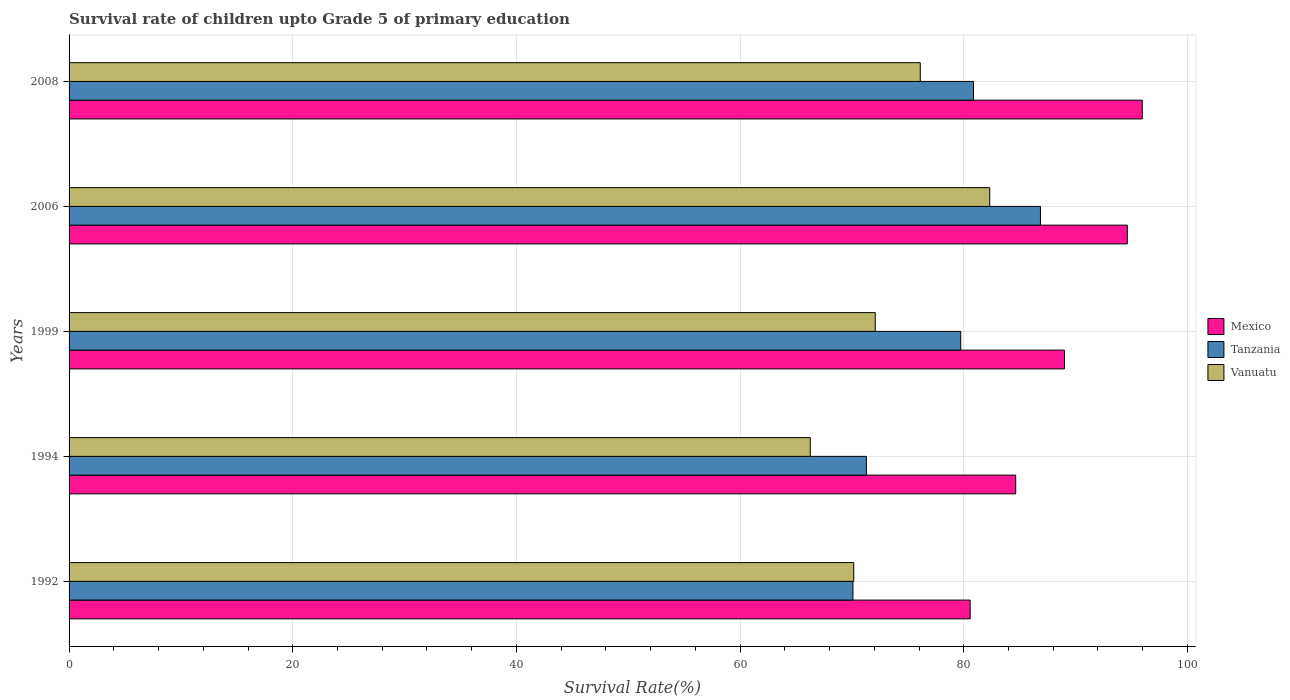Are the number of bars per tick equal to the number of legend labels?
Your response must be concise. Yes. Are the number of bars on each tick of the Y-axis equal?
Ensure brevity in your answer.  Yes. In how many cases, is the number of bars for a given year not equal to the number of legend labels?
Make the answer very short. 0. What is the survival rate of children in Mexico in 2008?
Provide a succinct answer. 95.96. Across all years, what is the maximum survival rate of children in Tanzania?
Provide a short and direct response. 86.86. Across all years, what is the minimum survival rate of children in Vanuatu?
Keep it short and to the point. 66.27. In which year was the survival rate of children in Mexico maximum?
Offer a very short reply. 2008. What is the total survival rate of children in Tanzania in the graph?
Ensure brevity in your answer.  388.84. What is the difference between the survival rate of children in Mexico in 1999 and that in 2008?
Give a very brief answer. -6.95. What is the difference between the survival rate of children in Mexico in 1994 and the survival rate of children in Vanuatu in 1999?
Ensure brevity in your answer.  12.56. What is the average survival rate of children in Mexico per year?
Offer a very short reply. 88.96. In the year 2008, what is the difference between the survival rate of children in Tanzania and survival rate of children in Vanuatu?
Your answer should be very brief. 4.76. In how many years, is the survival rate of children in Tanzania greater than 4 %?
Provide a succinct answer. 5. What is the ratio of the survival rate of children in Mexico in 1999 to that in 2008?
Offer a very short reply. 0.93. Is the survival rate of children in Vanuatu in 1999 less than that in 2006?
Offer a terse response. Yes. Is the difference between the survival rate of children in Tanzania in 1992 and 1994 greater than the difference between the survival rate of children in Vanuatu in 1992 and 1994?
Ensure brevity in your answer.  No. What is the difference between the highest and the second highest survival rate of children in Vanuatu?
Offer a very short reply. 6.21. What is the difference between the highest and the lowest survival rate of children in Mexico?
Make the answer very short. 15.39. In how many years, is the survival rate of children in Vanuatu greater than the average survival rate of children in Vanuatu taken over all years?
Offer a terse response. 2. What does the 2nd bar from the top in 2008 represents?
Your response must be concise. Tanzania. What does the 2nd bar from the bottom in 2006 represents?
Your response must be concise. Tanzania. How many bars are there?
Provide a succinct answer. 15. How many years are there in the graph?
Give a very brief answer. 5. What is the difference between two consecutive major ticks on the X-axis?
Keep it short and to the point. 20. How are the legend labels stacked?
Keep it short and to the point. Vertical. What is the title of the graph?
Provide a succinct answer. Survival rate of children upto Grade 5 of primary education. What is the label or title of the X-axis?
Offer a very short reply. Survival Rate(%). What is the Survival Rate(%) of Mexico in 1992?
Your response must be concise. 80.57. What is the Survival Rate(%) in Tanzania in 1992?
Provide a short and direct response. 70.09. What is the Survival Rate(%) of Vanuatu in 1992?
Keep it short and to the point. 70.16. What is the Survival Rate(%) of Mexico in 1994?
Offer a terse response. 84.64. What is the Survival Rate(%) of Tanzania in 1994?
Keep it short and to the point. 71.29. What is the Survival Rate(%) of Vanuatu in 1994?
Provide a short and direct response. 66.27. What is the Survival Rate(%) of Mexico in 1999?
Provide a short and direct response. 89. What is the Survival Rate(%) in Tanzania in 1999?
Make the answer very short. 79.73. What is the Survival Rate(%) in Vanuatu in 1999?
Provide a short and direct response. 72.08. What is the Survival Rate(%) of Mexico in 2006?
Provide a succinct answer. 94.62. What is the Survival Rate(%) of Tanzania in 2006?
Your response must be concise. 86.86. What is the Survival Rate(%) in Vanuatu in 2006?
Ensure brevity in your answer.  82.32. What is the Survival Rate(%) of Mexico in 2008?
Give a very brief answer. 95.96. What is the Survival Rate(%) in Tanzania in 2008?
Make the answer very short. 80.87. What is the Survival Rate(%) in Vanuatu in 2008?
Make the answer very short. 76.11. Across all years, what is the maximum Survival Rate(%) in Mexico?
Offer a terse response. 95.96. Across all years, what is the maximum Survival Rate(%) in Tanzania?
Offer a very short reply. 86.86. Across all years, what is the maximum Survival Rate(%) of Vanuatu?
Offer a terse response. 82.32. Across all years, what is the minimum Survival Rate(%) in Mexico?
Provide a short and direct response. 80.57. Across all years, what is the minimum Survival Rate(%) in Tanzania?
Provide a short and direct response. 70.09. Across all years, what is the minimum Survival Rate(%) in Vanuatu?
Ensure brevity in your answer.  66.27. What is the total Survival Rate(%) in Mexico in the graph?
Keep it short and to the point. 444.8. What is the total Survival Rate(%) in Tanzania in the graph?
Provide a succinct answer. 388.84. What is the total Survival Rate(%) of Vanuatu in the graph?
Give a very brief answer. 366.95. What is the difference between the Survival Rate(%) of Mexico in 1992 and that in 1994?
Offer a terse response. -4.07. What is the difference between the Survival Rate(%) of Tanzania in 1992 and that in 1994?
Your answer should be very brief. -1.2. What is the difference between the Survival Rate(%) of Vanuatu in 1992 and that in 1994?
Offer a terse response. 3.89. What is the difference between the Survival Rate(%) of Mexico in 1992 and that in 1999?
Give a very brief answer. -8.43. What is the difference between the Survival Rate(%) in Tanzania in 1992 and that in 1999?
Your response must be concise. -9.64. What is the difference between the Survival Rate(%) in Vanuatu in 1992 and that in 1999?
Give a very brief answer. -1.92. What is the difference between the Survival Rate(%) in Mexico in 1992 and that in 2006?
Provide a short and direct response. -14.05. What is the difference between the Survival Rate(%) of Tanzania in 1992 and that in 2006?
Offer a terse response. -16.77. What is the difference between the Survival Rate(%) in Vanuatu in 1992 and that in 2006?
Keep it short and to the point. -12.16. What is the difference between the Survival Rate(%) of Mexico in 1992 and that in 2008?
Keep it short and to the point. -15.39. What is the difference between the Survival Rate(%) in Tanzania in 1992 and that in 2008?
Keep it short and to the point. -10.77. What is the difference between the Survival Rate(%) in Vanuatu in 1992 and that in 2008?
Your answer should be very brief. -5.95. What is the difference between the Survival Rate(%) in Mexico in 1994 and that in 1999?
Offer a terse response. -4.36. What is the difference between the Survival Rate(%) of Tanzania in 1994 and that in 1999?
Keep it short and to the point. -8.43. What is the difference between the Survival Rate(%) of Vanuatu in 1994 and that in 1999?
Give a very brief answer. -5.81. What is the difference between the Survival Rate(%) of Mexico in 1994 and that in 2006?
Offer a very short reply. -9.98. What is the difference between the Survival Rate(%) in Tanzania in 1994 and that in 2006?
Provide a succinct answer. -15.56. What is the difference between the Survival Rate(%) in Vanuatu in 1994 and that in 2006?
Keep it short and to the point. -16.05. What is the difference between the Survival Rate(%) in Mexico in 1994 and that in 2008?
Provide a short and direct response. -11.32. What is the difference between the Survival Rate(%) in Tanzania in 1994 and that in 2008?
Your response must be concise. -9.57. What is the difference between the Survival Rate(%) in Vanuatu in 1994 and that in 2008?
Keep it short and to the point. -9.84. What is the difference between the Survival Rate(%) of Mexico in 1999 and that in 2006?
Ensure brevity in your answer.  -5.62. What is the difference between the Survival Rate(%) of Tanzania in 1999 and that in 2006?
Make the answer very short. -7.13. What is the difference between the Survival Rate(%) in Vanuatu in 1999 and that in 2006?
Make the answer very short. -10.24. What is the difference between the Survival Rate(%) in Mexico in 1999 and that in 2008?
Keep it short and to the point. -6.95. What is the difference between the Survival Rate(%) in Tanzania in 1999 and that in 2008?
Give a very brief answer. -1.14. What is the difference between the Survival Rate(%) of Vanuatu in 1999 and that in 2008?
Give a very brief answer. -4.03. What is the difference between the Survival Rate(%) of Mexico in 2006 and that in 2008?
Keep it short and to the point. -1.34. What is the difference between the Survival Rate(%) in Tanzania in 2006 and that in 2008?
Offer a very short reply. 5.99. What is the difference between the Survival Rate(%) of Vanuatu in 2006 and that in 2008?
Your response must be concise. 6.21. What is the difference between the Survival Rate(%) of Mexico in 1992 and the Survival Rate(%) of Tanzania in 1994?
Your answer should be very brief. 9.28. What is the difference between the Survival Rate(%) in Mexico in 1992 and the Survival Rate(%) in Vanuatu in 1994?
Your response must be concise. 14.3. What is the difference between the Survival Rate(%) of Tanzania in 1992 and the Survival Rate(%) of Vanuatu in 1994?
Provide a short and direct response. 3.82. What is the difference between the Survival Rate(%) of Mexico in 1992 and the Survival Rate(%) of Tanzania in 1999?
Give a very brief answer. 0.84. What is the difference between the Survival Rate(%) of Mexico in 1992 and the Survival Rate(%) of Vanuatu in 1999?
Make the answer very short. 8.49. What is the difference between the Survival Rate(%) of Tanzania in 1992 and the Survival Rate(%) of Vanuatu in 1999?
Keep it short and to the point. -1.99. What is the difference between the Survival Rate(%) of Mexico in 1992 and the Survival Rate(%) of Tanzania in 2006?
Make the answer very short. -6.29. What is the difference between the Survival Rate(%) in Mexico in 1992 and the Survival Rate(%) in Vanuatu in 2006?
Offer a very short reply. -1.75. What is the difference between the Survival Rate(%) in Tanzania in 1992 and the Survival Rate(%) in Vanuatu in 2006?
Provide a succinct answer. -12.23. What is the difference between the Survival Rate(%) of Mexico in 1992 and the Survival Rate(%) of Tanzania in 2008?
Provide a short and direct response. -0.29. What is the difference between the Survival Rate(%) of Mexico in 1992 and the Survival Rate(%) of Vanuatu in 2008?
Keep it short and to the point. 4.46. What is the difference between the Survival Rate(%) in Tanzania in 1992 and the Survival Rate(%) in Vanuatu in 2008?
Your response must be concise. -6.02. What is the difference between the Survival Rate(%) in Mexico in 1994 and the Survival Rate(%) in Tanzania in 1999?
Your answer should be compact. 4.91. What is the difference between the Survival Rate(%) in Mexico in 1994 and the Survival Rate(%) in Vanuatu in 1999?
Offer a very short reply. 12.56. What is the difference between the Survival Rate(%) in Tanzania in 1994 and the Survival Rate(%) in Vanuatu in 1999?
Keep it short and to the point. -0.79. What is the difference between the Survival Rate(%) in Mexico in 1994 and the Survival Rate(%) in Tanzania in 2006?
Provide a short and direct response. -2.21. What is the difference between the Survival Rate(%) of Mexico in 1994 and the Survival Rate(%) of Vanuatu in 2006?
Give a very brief answer. 2.32. What is the difference between the Survival Rate(%) in Tanzania in 1994 and the Survival Rate(%) in Vanuatu in 2006?
Offer a very short reply. -11.03. What is the difference between the Survival Rate(%) of Mexico in 1994 and the Survival Rate(%) of Tanzania in 2008?
Give a very brief answer. 3.78. What is the difference between the Survival Rate(%) of Mexico in 1994 and the Survival Rate(%) of Vanuatu in 2008?
Provide a short and direct response. 8.53. What is the difference between the Survival Rate(%) in Tanzania in 1994 and the Survival Rate(%) in Vanuatu in 2008?
Give a very brief answer. -4.82. What is the difference between the Survival Rate(%) in Mexico in 1999 and the Survival Rate(%) in Tanzania in 2006?
Your response must be concise. 2.15. What is the difference between the Survival Rate(%) in Mexico in 1999 and the Survival Rate(%) in Vanuatu in 2006?
Your answer should be very brief. 6.68. What is the difference between the Survival Rate(%) in Tanzania in 1999 and the Survival Rate(%) in Vanuatu in 2006?
Offer a terse response. -2.59. What is the difference between the Survival Rate(%) of Mexico in 1999 and the Survival Rate(%) of Tanzania in 2008?
Offer a terse response. 8.14. What is the difference between the Survival Rate(%) in Mexico in 1999 and the Survival Rate(%) in Vanuatu in 2008?
Ensure brevity in your answer.  12.89. What is the difference between the Survival Rate(%) of Tanzania in 1999 and the Survival Rate(%) of Vanuatu in 2008?
Give a very brief answer. 3.62. What is the difference between the Survival Rate(%) in Mexico in 2006 and the Survival Rate(%) in Tanzania in 2008?
Offer a very short reply. 13.75. What is the difference between the Survival Rate(%) of Mexico in 2006 and the Survival Rate(%) of Vanuatu in 2008?
Make the answer very short. 18.51. What is the difference between the Survival Rate(%) of Tanzania in 2006 and the Survival Rate(%) of Vanuatu in 2008?
Keep it short and to the point. 10.75. What is the average Survival Rate(%) in Mexico per year?
Make the answer very short. 88.96. What is the average Survival Rate(%) of Tanzania per year?
Make the answer very short. 77.77. What is the average Survival Rate(%) in Vanuatu per year?
Provide a short and direct response. 73.39. In the year 1992, what is the difference between the Survival Rate(%) in Mexico and Survival Rate(%) in Tanzania?
Provide a short and direct response. 10.48. In the year 1992, what is the difference between the Survival Rate(%) in Mexico and Survival Rate(%) in Vanuatu?
Give a very brief answer. 10.41. In the year 1992, what is the difference between the Survival Rate(%) in Tanzania and Survival Rate(%) in Vanuatu?
Your response must be concise. -0.07. In the year 1994, what is the difference between the Survival Rate(%) of Mexico and Survival Rate(%) of Tanzania?
Make the answer very short. 13.35. In the year 1994, what is the difference between the Survival Rate(%) in Mexico and Survival Rate(%) in Vanuatu?
Ensure brevity in your answer.  18.37. In the year 1994, what is the difference between the Survival Rate(%) in Tanzania and Survival Rate(%) in Vanuatu?
Make the answer very short. 5.02. In the year 1999, what is the difference between the Survival Rate(%) of Mexico and Survival Rate(%) of Tanzania?
Keep it short and to the point. 9.28. In the year 1999, what is the difference between the Survival Rate(%) of Mexico and Survival Rate(%) of Vanuatu?
Your answer should be compact. 16.92. In the year 1999, what is the difference between the Survival Rate(%) of Tanzania and Survival Rate(%) of Vanuatu?
Give a very brief answer. 7.64. In the year 2006, what is the difference between the Survival Rate(%) of Mexico and Survival Rate(%) of Tanzania?
Provide a succinct answer. 7.76. In the year 2006, what is the difference between the Survival Rate(%) in Mexico and Survival Rate(%) in Vanuatu?
Your response must be concise. 12.3. In the year 2006, what is the difference between the Survival Rate(%) of Tanzania and Survival Rate(%) of Vanuatu?
Keep it short and to the point. 4.54. In the year 2008, what is the difference between the Survival Rate(%) of Mexico and Survival Rate(%) of Tanzania?
Keep it short and to the point. 15.09. In the year 2008, what is the difference between the Survival Rate(%) of Mexico and Survival Rate(%) of Vanuatu?
Offer a very short reply. 19.85. In the year 2008, what is the difference between the Survival Rate(%) of Tanzania and Survival Rate(%) of Vanuatu?
Your answer should be compact. 4.76. What is the ratio of the Survival Rate(%) in Mexico in 1992 to that in 1994?
Offer a very short reply. 0.95. What is the ratio of the Survival Rate(%) in Tanzania in 1992 to that in 1994?
Provide a short and direct response. 0.98. What is the ratio of the Survival Rate(%) of Vanuatu in 1992 to that in 1994?
Offer a very short reply. 1.06. What is the ratio of the Survival Rate(%) of Mexico in 1992 to that in 1999?
Your answer should be compact. 0.91. What is the ratio of the Survival Rate(%) of Tanzania in 1992 to that in 1999?
Give a very brief answer. 0.88. What is the ratio of the Survival Rate(%) of Vanuatu in 1992 to that in 1999?
Ensure brevity in your answer.  0.97. What is the ratio of the Survival Rate(%) in Mexico in 1992 to that in 2006?
Your answer should be compact. 0.85. What is the ratio of the Survival Rate(%) of Tanzania in 1992 to that in 2006?
Give a very brief answer. 0.81. What is the ratio of the Survival Rate(%) in Vanuatu in 1992 to that in 2006?
Your answer should be very brief. 0.85. What is the ratio of the Survival Rate(%) in Mexico in 1992 to that in 2008?
Your response must be concise. 0.84. What is the ratio of the Survival Rate(%) of Tanzania in 1992 to that in 2008?
Your answer should be very brief. 0.87. What is the ratio of the Survival Rate(%) in Vanuatu in 1992 to that in 2008?
Give a very brief answer. 0.92. What is the ratio of the Survival Rate(%) in Mexico in 1994 to that in 1999?
Give a very brief answer. 0.95. What is the ratio of the Survival Rate(%) in Tanzania in 1994 to that in 1999?
Provide a succinct answer. 0.89. What is the ratio of the Survival Rate(%) in Vanuatu in 1994 to that in 1999?
Your answer should be compact. 0.92. What is the ratio of the Survival Rate(%) of Mexico in 1994 to that in 2006?
Offer a terse response. 0.89. What is the ratio of the Survival Rate(%) of Tanzania in 1994 to that in 2006?
Give a very brief answer. 0.82. What is the ratio of the Survival Rate(%) of Vanuatu in 1994 to that in 2006?
Keep it short and to the point. 0.81. What is the ratio of the Survival Rate(%) of Mexico in 1994 to that in 2008?
Your answer should be very brief. 0.88. What is the ratio of the Survival Rate(%) in Tanzania in 1994 to that in 2008?
Your answer should be very brief. 0.88. What is the ratio of the Survival Rate(%) in Vanuatu in 1994 to that in 2008?
Keep it short and to the point. 0.87. What is the ratio of the Survival Rate(%) in Mexico in 1999 to that in 2006?
Offer a terse response. 0.94. What is the ratio of the Survival Rate(%) in Tanzania in 1999 to that in 2006?
Make the answer very short. 0.92. What is the ratio of the Survival Rate(%) in Vanuatu in 1999 to that in 2006?
Give a very brief answer. 0.88. What is the ratio of the Survival Rate(%) in Mexico in 1999 to that in 2008?
Keep it short and to the point. 0.93. What is the ratio of the Survival Rate(%) in Tanzania in 1999 to that in 2008?
Give a very brief answer. 0.99. What is the ratio of the Survival Rate(%) of Vanuatu in 1999 to that in 2008?
Your response must be concise. 0.95. What is the ratio of the Survival Rate(%) of Mexico in 2006 to that in 2008?
Your answer should be compact. 0.99. What is the ratio of the Survival Rate(%) of Tanzania in 2006 to that in 2008?
Your answer should be very brief. 1.07. What is the ratio of the Survival Rate(%) in Vanuatu in 2006 to that in 2008?
Provide a short and direct response. 1.08. What is the difference between the highest and the second highest Survival Rate(%) in Mexico?
Keep it short and to the point. 1.34. What is the difference between the highest and the second highest Survival Rate(%) in Tanzania?
Keep it short and to the point. 5.99. What is the difference between the highest and the second highest Survival Rate(%) of Vanuatu?
Provide a succinct answer. 6.21. What is the difference between the highest and the lowest Survival Rate(%) in Mexico?
Ensure brevity in your answer.  15.39. What is the difference between the highest and the lowest Survival Rate(%) in Tanzania?
Offer a terse response. 16.77. What is the difference between the highest and the lowest Survival Rate(%) of Vanuatu?
Give a very brief answer. 16.05. 